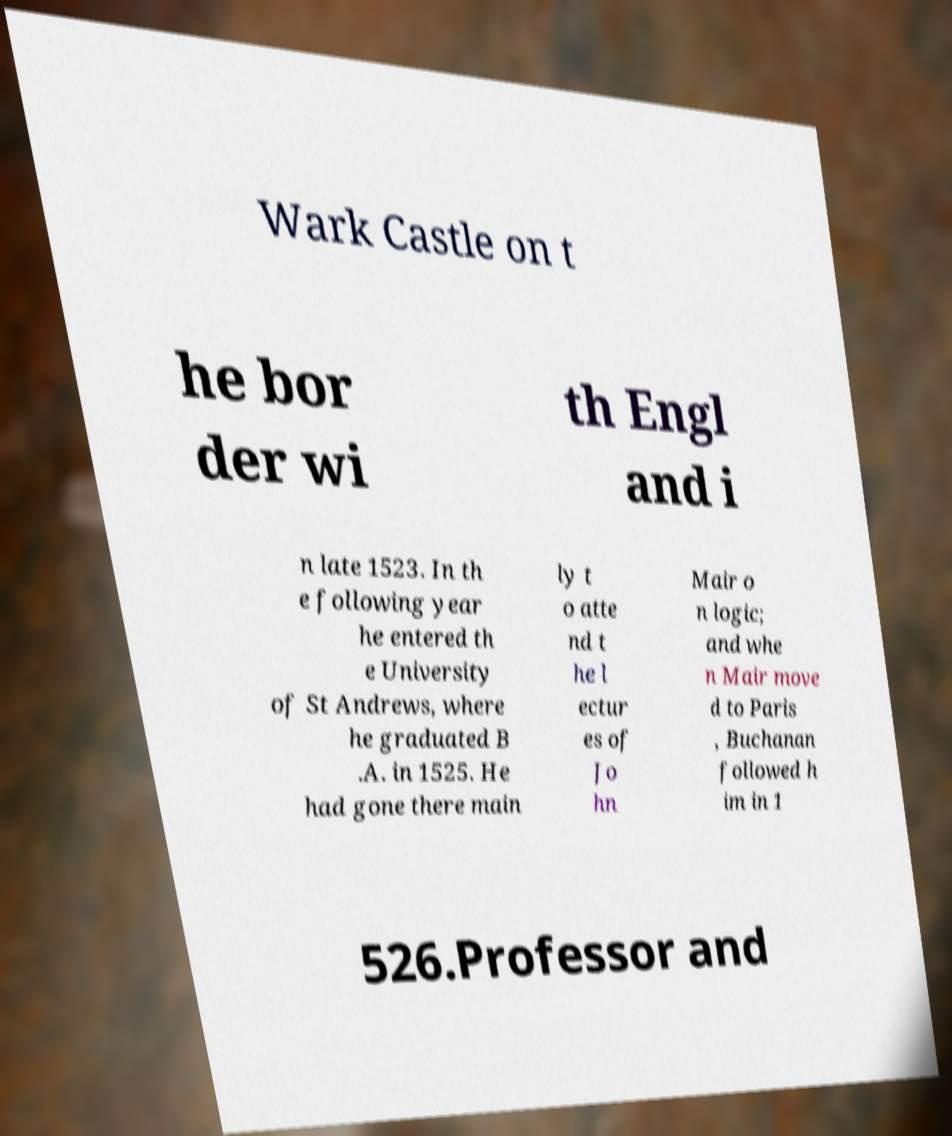I need the written content from this picture converted into text. Can you do that? Wark Castle on t he bor der wi th Engl and i n late 1523. In th e following year he entered th e University of St Andrews, where he graduated B .A. in 1525. He had gone there main ly t o atte nd t he l ectur es of Jo hn Mair o n logic; and whe n Mair move d to Paris , Buchanan followed h im in 1 526.Professor and 